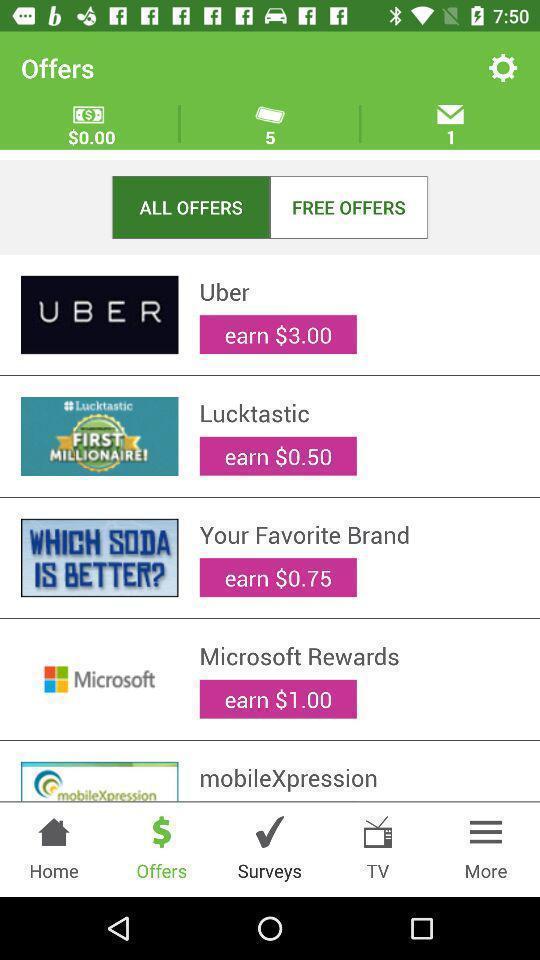Summarize the information in this screenshot. Screen showing the list of offer available. 